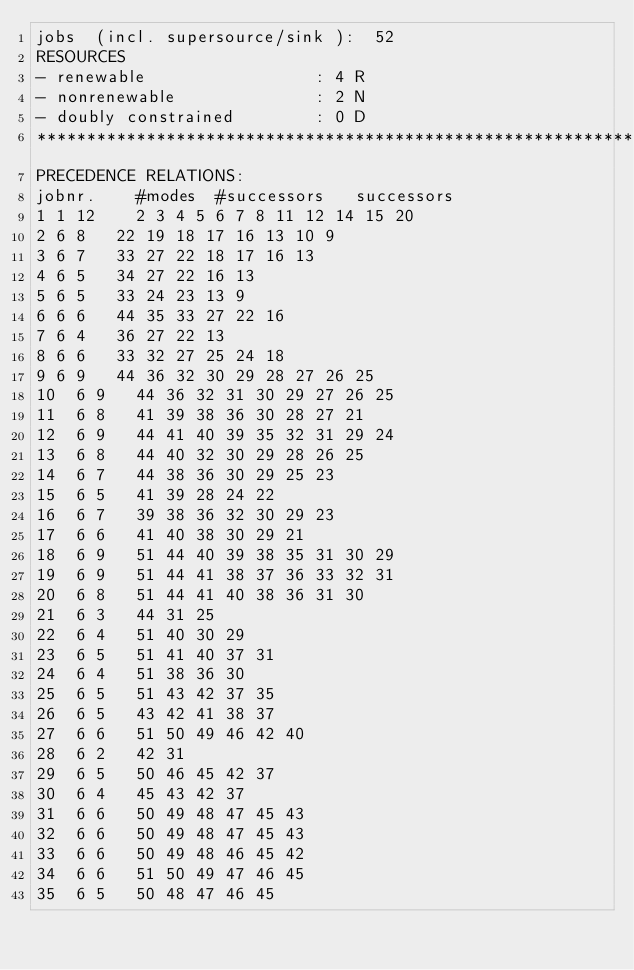<code> <loc_0><loc_0><loc_500><loc_500><_ObjectiveC_>jobs  (incl. supersource/sink ):	52
RESOURCES
- renewable                 : 4 R
- nonrenewable              : 2 N
- doubly constrained        : 0 D
************************************************************************
PRECEDENCE RELATIONS:
jobnr.    #modes  #successors   successors
1	1	12		2 3 4 5 6 7 8 11 12 14 15 20 
2	6	8		22 19 18 17 16 13 10 9 
3	6	7		33 27 22 18 17 16 13 
4	6	5		34 27 22 16 13 
5	6	5		33 24 23 13 9 
6	6	6		44 35 33 27 22 16 
7	6	4		36 27 22 13 
8	6	6		33 32 27 25 24 18 
9	6	9		44 36 32 30 29 28 27 26 25 
10	6	9		44 36 32 31 30 29 27 26 25 
11	6	8		41 39 38 36 30 28 27 21 
12	6	9		44 41 40 39 35 32 31 29 24 
13	6	8		44 40 32 30 29 28 26 25 
14	6	7		44 38 36 30 29 25 23 
15	6	5		41 39 28 24 22 
16	6	7		39 38 36 32 30 29 23 
17	6	6		41 40 38 30 29 21 
18	6	9		51 44 40 39 38 35 31 30 29 
19	6	9		51 44 41 38 37 36 33 32 31 
20	6	8		51 44 41 40 38 36 31 30 
21	6	3		44 31 25 
22	6	4		51 40 30 29 
23	6	5		51 41 40 37 31 
24	6	4		51 38 36 30 
25	6	5		51 43 42 37 35 
26	6	5		43 42 41 38 37 
27	6	6		51 50 49 46 42 40 
28	6	2		42 31 
29	6	5		50 46 45 42 37 
30	6	4		45 43 42 37 
31	6	6		50 49 48 47 45 43 
32	6	6		50 49 48 47 45 43 
33	6	6		50 49 48 46 45 42 
34	6	6		51 50 49 47 46 45 
35	6	5		50 48 47 46 45 </code> 